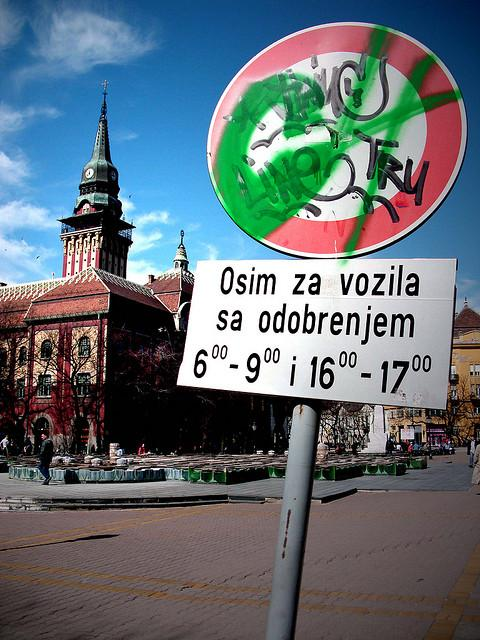What are the green markings an example of?

Choices:
A) art
B) typing
C) mural
D) graffiti graffiti 